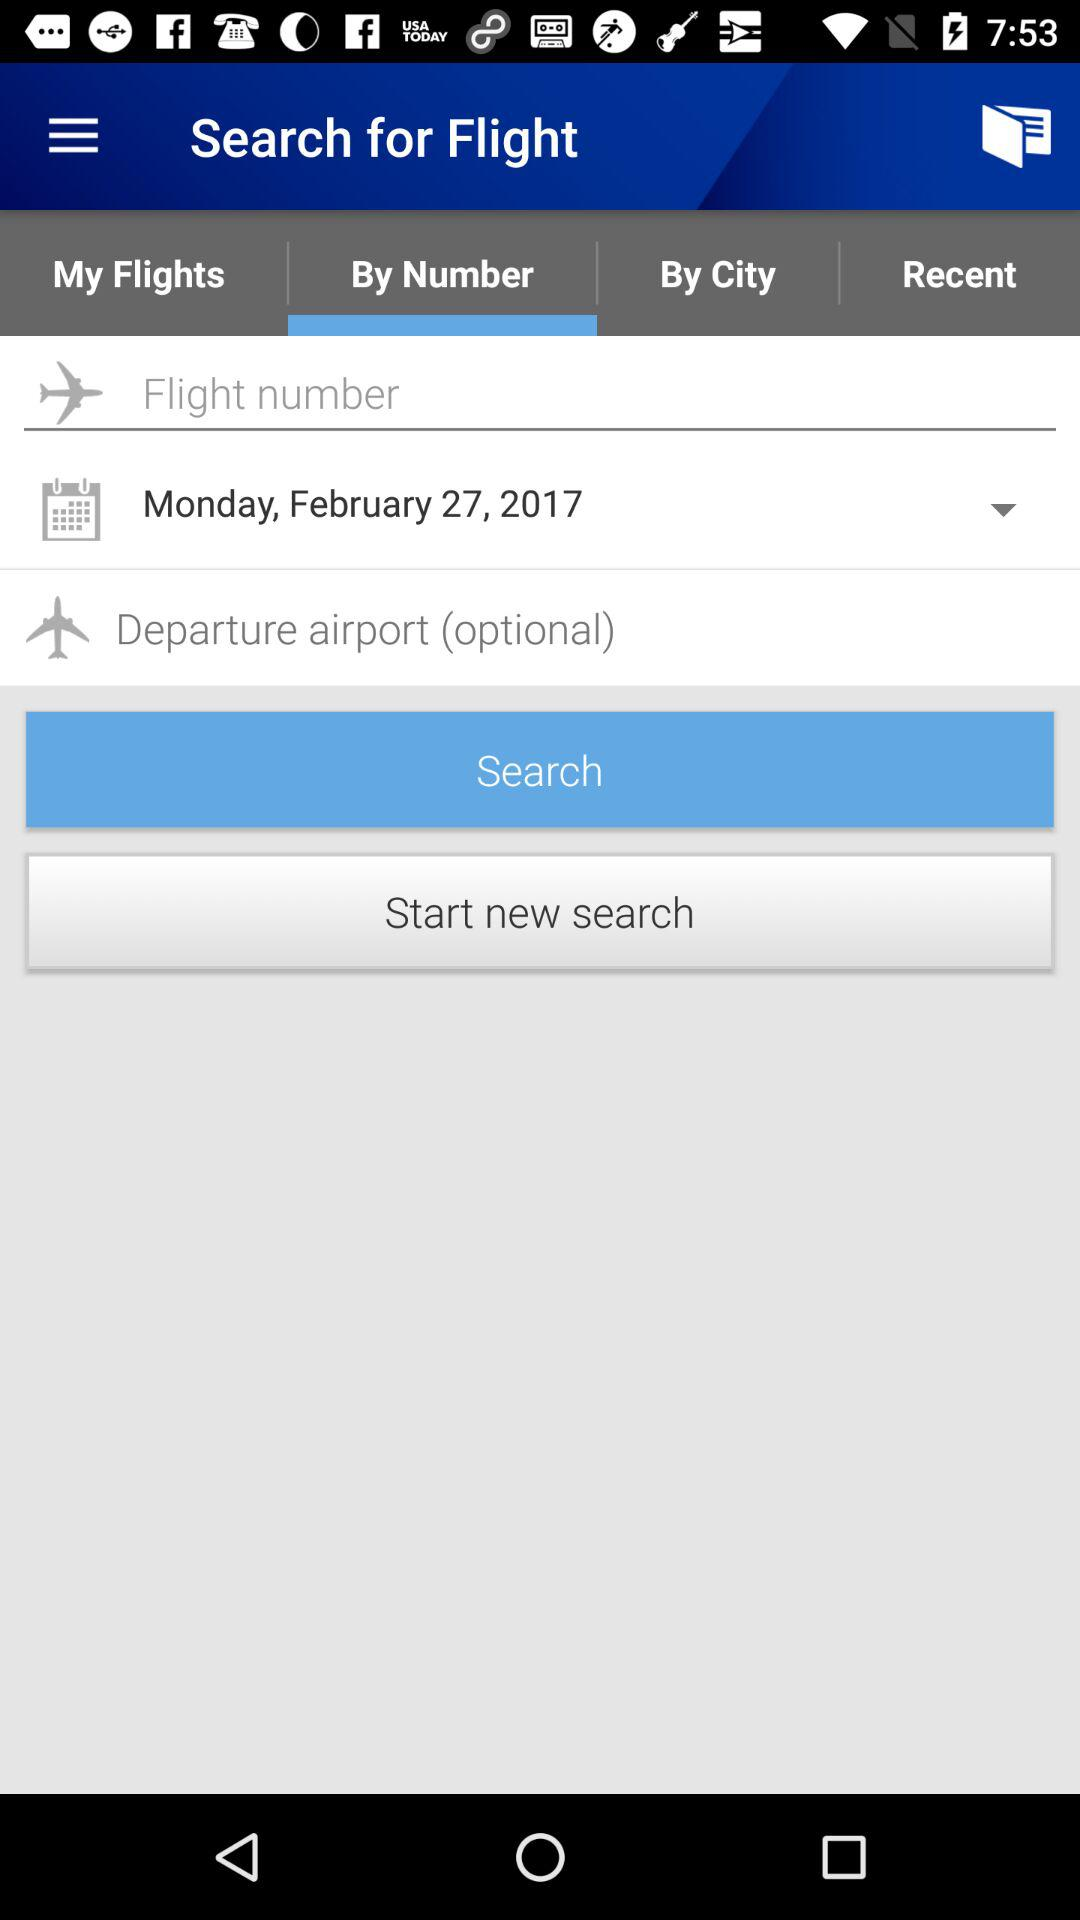Which is the selected date? The selected date is Monday, February 27, 2017. 